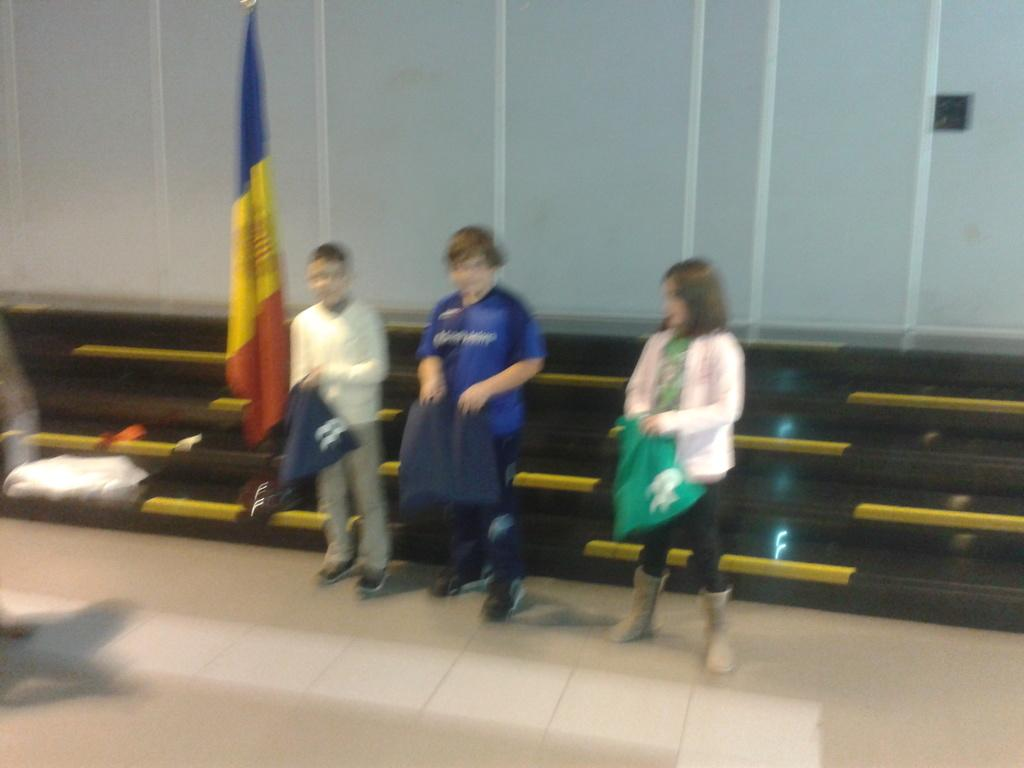What are the persons in the image doing? The persons in the image are standing on the floor and holding clothes in their hands. What can be seen in the image besides the persons and their actions? There is a flag visible in the image. What is the background of the image composed of? There are walls in the background of the image. What type of spark can be seen coming from the horn in the image? There is no horn or spark present in the image. 